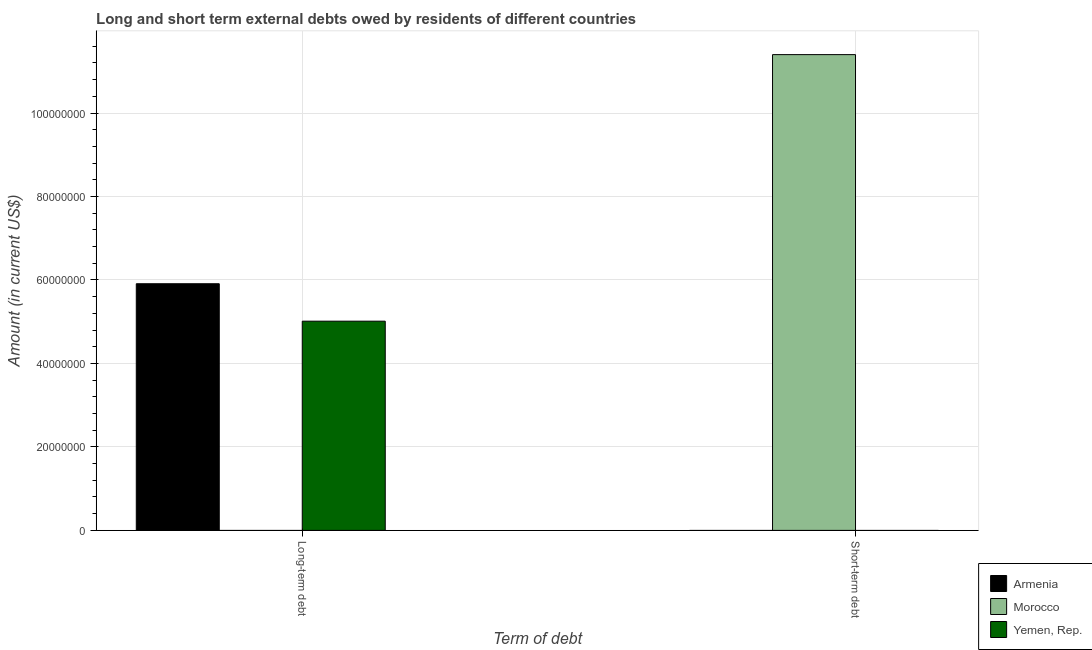Are the number of bars per tick equal to the number of legend labels?
Make the answer very short. No. Are the number of bars on each tick of the X-axis equal?
Provide a short and direct response. No. What is the label of the 2nd group of bars from the left?
Your response must be concise. Short-term debt. What is the long-term debts owed by residents in Morocco?
Offer a very short reply. 0. Across all countries, what is the maximum short-term debts owed by residents?
Offer a terse response. 1.14e+08. In which country was the short-term debts owed by residents maximum?
Offer a terse response. Morocco. What is the total short-term debts owed by residents in the graph?
Provide a short and direct response. 1.14e+08. What is the difference between the long-term debts owed by residents in Yemen, Rep. and that in Armenia?
Your response must be concise. -8.97e+06. What is the difference between the short-term debts owed by residents in Morocco and the long-term debts owed by residents in Yemen, Rep.?
Make the answer very short. 6.39e+07. What is the average long-term debts owed by residents per country?
Offer a terse response. 3.64e+07. In how many countries, is the short-term debts owed by residents greater than 108000000 US$?
Provide a succinct answer. 1. What is the ratio of the long-term debts owed by residents in Armenia to that in Yemen, Rep.?
Make the answer very short. 1.18. How are the legend labels stacked?
Provide a succinct answer. Vertical. What is the title of the graph?
Ensure brevity in your answer.  Long and short term external debts owed by residents of different countries. What is the label or title of the X-axis?
Your answer should be compact. Term of debt. What is the Amount (in current US$) in Armenia in Long-term debt?
Your answer should be very brief. 5.91e+07. What is the Amount (in current US$) of Morocco in Long-term debt?
Provide a succinct answer. 0. What is the Amount (in current US$) in Yemen, Rep. in Long-term debt?
Provide a short and direct response. 5.01e+07. What is the Amount (in current US$) in Armenia in Short-term debt?
Provide a short and direct response. 0. What is the Amount (in current US$) of Morocco in Short-term debt?
Provide a succinct answer. 1.14e+08. What is the Amount (in current US$) of Yemen, Rep. in Short-term debt?
Your answer should be very brief. 0. Across all Term of debt, what is the maximum Amount (in current US$) of Armenia?
Offer a very short reply. 5.91e+07. Across all Term of debt, what is the maximum Amount (in current US$) of Morocco?
Provide a succinct answer. 1.14e+08. Across all Term of debt, what is the maximum Amount (in current US$) in Yemen, Rep.?
Ensure brevity in your answer.  5.01e+07. Across all Term of debt, what is the minimum Amount (in current US$) in Armenia?
Provide a short and direct response. 0. Across all Term of debt, what is the minimum Amount (in current US$) of Morocco?
Keep it short and to the point. 0. What is the total Amount (in current US$) of Armenia in the graph?
Offer a terse response. 5.91e+07. What is the total Amount (in current US$) of Morocco in the graph?
Make the answer very short. 1.14e+08. What is the total Amount (in current US$) of Yemen, Rep. in the graph?
Ensure brevity in your answer.  5.01e+07. What is the difference between the Amount (in current US$) in Armenia in Long-term debt and the Amount (in current US$) in Morocco in Short-term debt?
Your answer should be compact. -5.49e+07. What is the average Amount (in current US$) of Armenia per Term of debt?
Offer a terse response. 2.95e+07. What is the average Amount (in current US$) in Morocco per Term of debt?
Your answer should be very brief. 5.70e+07. What is the average Amount (in current US$) in Yemen, Rep. per Term of debt?
Offer a terse response. 2.51e+07. What is the difference between the Amount (in current US$) of Armenia and Amount (in current US$) of Yemen, Rep. in Long-term debt?
Your response must be concise. 8.97e+06. What is the difference between the highest and the lowest Amount (in current US$) of Armenia?
Your answer should be compact. 5.91e+07. What is the difference between the highest and the lowest Amount (in current US$) of Morocco?
Your answer should be very brief. 1.14e+08. What is the difference between the highest and the lowest Amount (in current US$) in Yemen, Rep.?
Your response must be concise. 5.01e+07. 